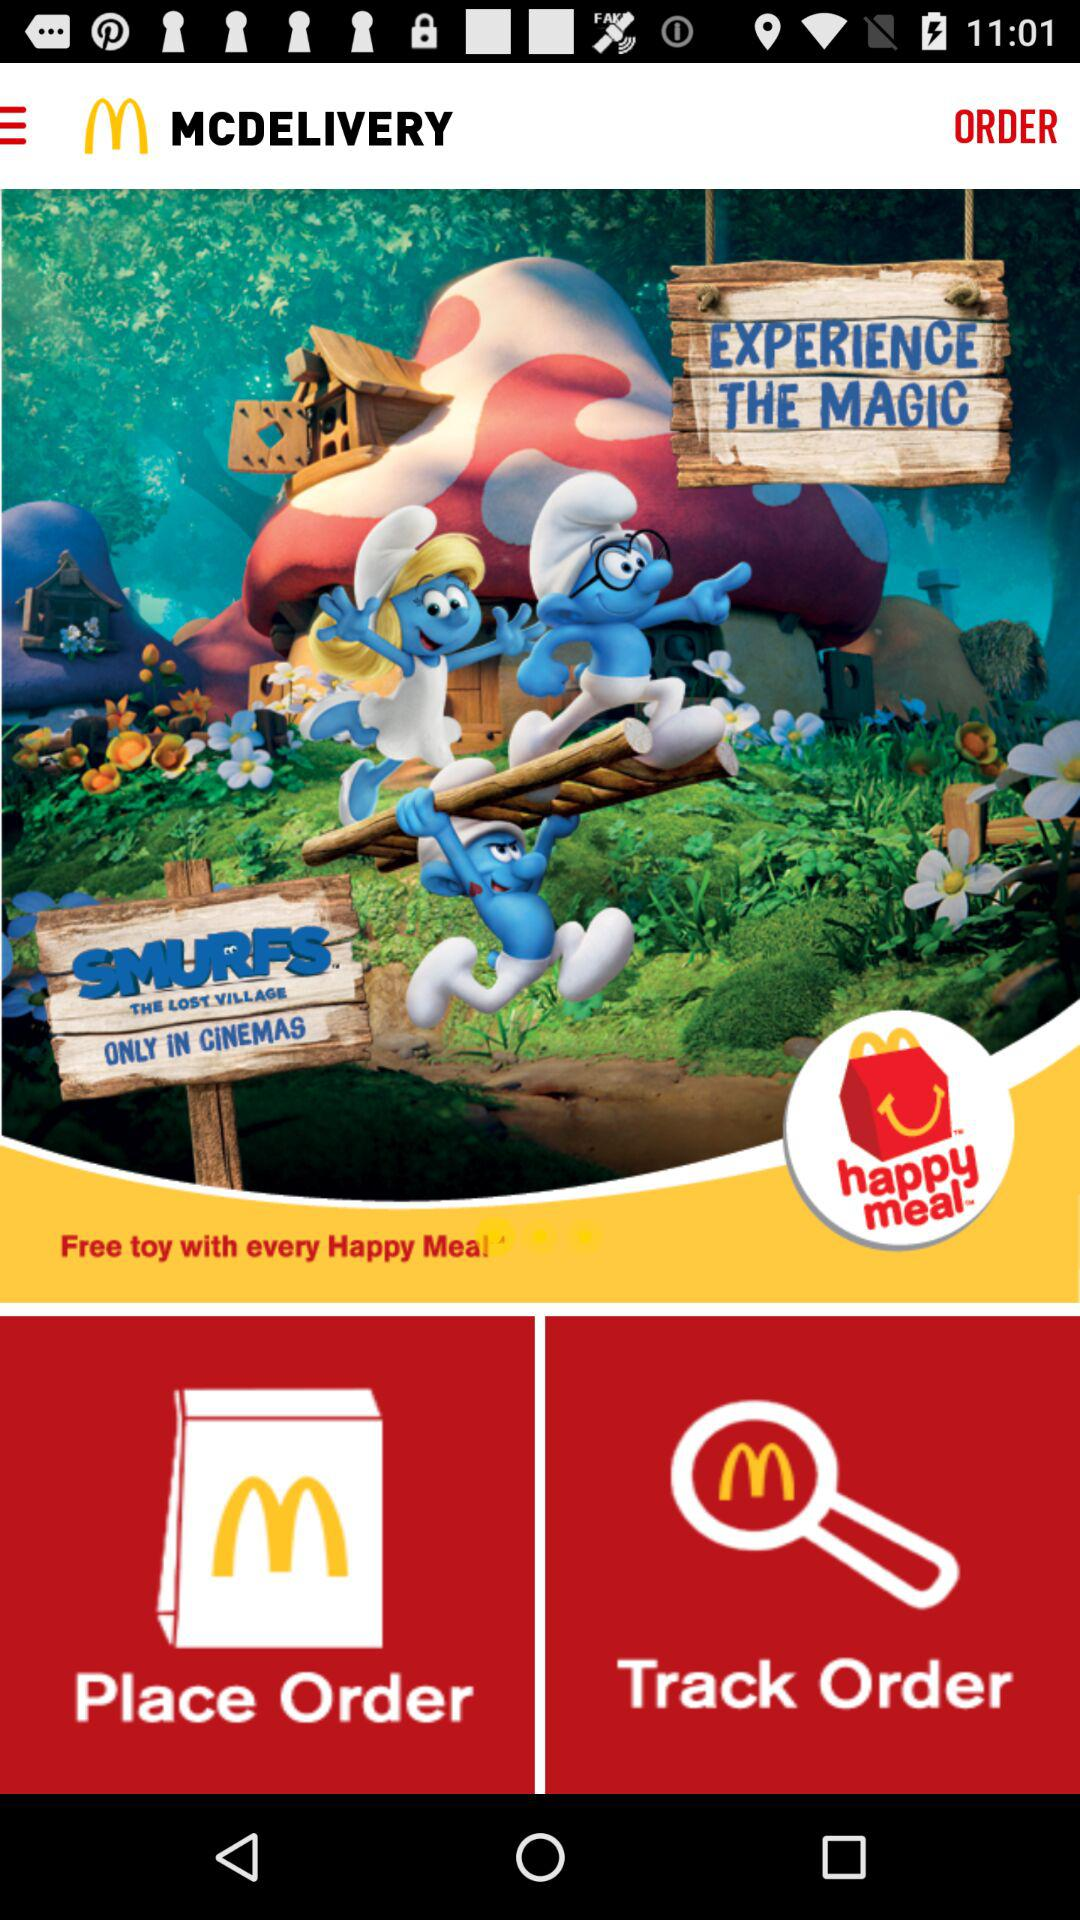What is the name of the application? The name of the application is "MCDELIVERY". 